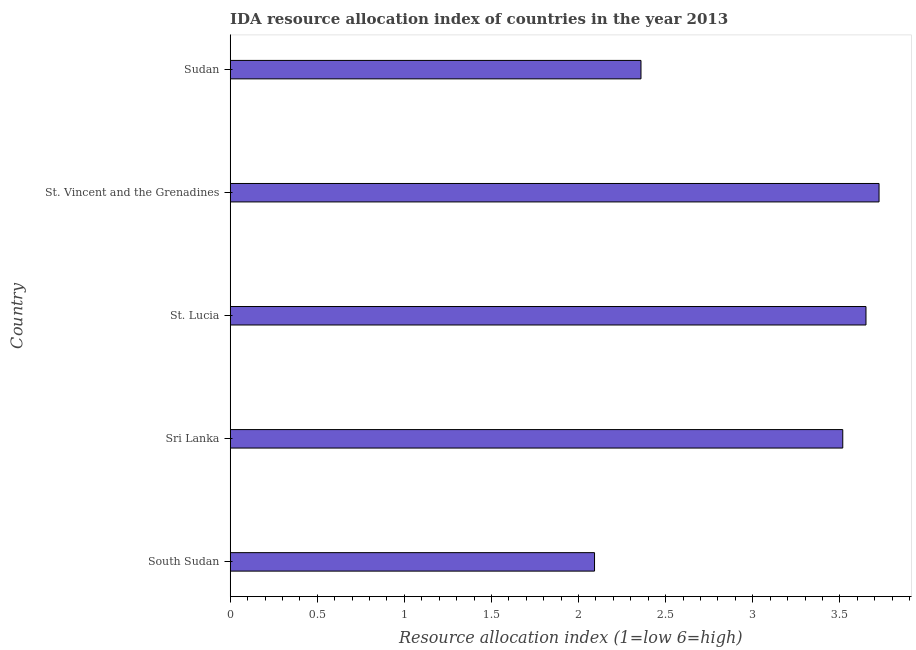Does the graph contain grids?
Offer a terse response. No. What is the title of the graph?
Provide a succinct answer. IDA resource allocation index of countries in the year 2013. What is the label or title of the X-axis?
Ensure brevity in your answer.  Resource allocation index (1=low 6=high). What is the ida resource allocation index in St. Lucia?
Provide a succinct answer. 3.65. Across all countries, what is the maximum ida resource allocation index?
Provide a short and direct response. 3.73. Across all countries, what is the minimum ida resource allocation index?
Ensure brevity in your answer.  2.09. In which country was the ida resource allocation index maximum?
Provide a short and direct response. St. Vincent and the Grenadines. In which country was the ida resource allocation index minimum?
Your response must be concise. South Sudan. What is the sum of the ida resource allocation index?
Offer a very short reply. 15.34. What is the difference between the ida resource allocation index in South Sudan and St. Vincent and the Grenadines?
Give a very brief answer. -1.63. What is the average ida resource allocation index per country?
Offer a very short reply. 3.07. What is the median ida resource allocation index?
Provide a short and direct response. 3.52. What is the ratio of the ida resource allocation index in Sri Lanka to that in St. Lucia?
Give a very brief answer. 0.96. What is the difference between the highest and the second highest ida resource allocation index?
Ensure brevity in your answer.  0.07. Is the sum of the ida resource allocation index in South Sudan and St. Lucia greater than the maximum ida resource allocation index across all countries?
Offer a very short reply. Yes. What is the difference between the highest and the lowest ida resource allocation index?
Provide a succinct answer. 1.63. In how many countries, is the ida resource allocation index greater than the average ida resource allocation index taken over all countries?
Keep it short and to the point. 3. Are all the bars in the graph horizontal?
Ensure brevity in your answer.  Yes. How many countries are there in the graph?
Keep it short and to the point. 5. What is the difference between two consecutive major ticks on the X-axis?
Ensure brevity in your answer.  0.5. What is the Resource allocation index (1=low 6=high) in South Sudan?
Provide a short and direct response. 2.09. What is the Resource allocation index (1=low 6=high) in Sri Lanka?
Your response must be concise. 3.52. What is the Resource allocation index (1=low 6=high) of St. Lucia?
Provide a short and direct response. 3.65. What is the Resource allocation index (1=low 6=high) in St. Vincent and the Grenadines?
Give a very brief answer. 3.73. What is the Resource allocation index (1=low 6=high) of Sudan?
Offer a terse response. 2.36. What is the difference between the Resource allocation index (1=low 6=high) in South Sudan and Sri Lanka?
Keep it short and to the point. -1.43. What is the difference between the Resource allocation index (1=low 6=high) in South Sudan and St. Lucia?
Make the answer very short. -1.56. What is the difference between the Resource allocation index (1=low 6=high) in South Sudan and St. Vincent and the Grenadines?
Your answer should be very brief. -1.63. What is the difference between the Resource allocation index (1=low 6=high) in South Sudan and Sudan?
Make the answer very short. -0.27. What is the difference between the Resource allocation index (1=low 6=high) in Sri Lanka and St. Lucia?
Offer a very short reply. -0.13. What is the difference between the Resource allocation index (1=low 6=high) in Sri Lanka and St. Vincent and the Grenadines?
Give a very brief answer. -0.21. What is the difference between the Resource allocation index (1=low 6=high) in Sri Lanka and Sudan?
Make the answer very short. 1.16. What is the difference between the Resource allocation index (1=low 6=high) in St. Lucia and St. Vincent and the Grenadines?
Provide a short and direct response. -0.07. What is the difference between the Resource allocation index (1=low 6=high) in St. Lucia and Sudan?
Keep it short and to the point. 1.29. What is the difference between the Resource allocation index (1=low 6=high) in St. Vincent and the Grenadines and Sudan?
Your answer should be very brief. 1.37. What is the ratio of the Resource allocation index (1=low 6=high) in South Sudan to that in Sri Lanka?
Your answer should be compact. 0.59. What is the ratio of the Resource allocation index (1=low 6=high) in South Sudan to that in St. Lucia?
Offer a terse response. 0.57. What is the ratio of the Resource allocation index (1=low 6=high) in South Sudan to that in St. Vincent and the Grenadines?
Your response must be concise. 0.56. What is the ratio of the Resource allocation index (1=low 6=high) in South Sudan to that in Sudan?
Offer a terse response. 0.89. What is the ratio of the Resource allocation index (1=low 6=high) in Sri Lanka to that in St. Lucia?
Provide a succinct answer. 0.96. What is the ratio of the Resource allocation index (1=low 6=high) in Sri Lanka to that in St. Vincent and the Grenadines?
Offer a very short reply. 0.94. What is the ratio of the Resource allocation index (1=low 6=high) in Sri Lanka to that in Sudan?
Your response must be concise. 1.49. What is the ratio of the Resource allocation index (1=low 6=high) in St. Lucia to that in Sudan?
Your answer should be compact. 1.55. What is the ratio of the Resource allocation index (1=low 6=high) in St. Vincent and the Grenadines to that in Sudan?
Give a very brief answer. 1.58. 